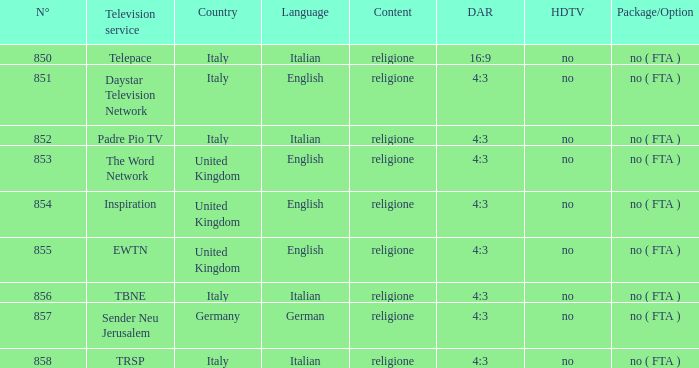Which television provider in italy features english programming? Daystar Television Network. 